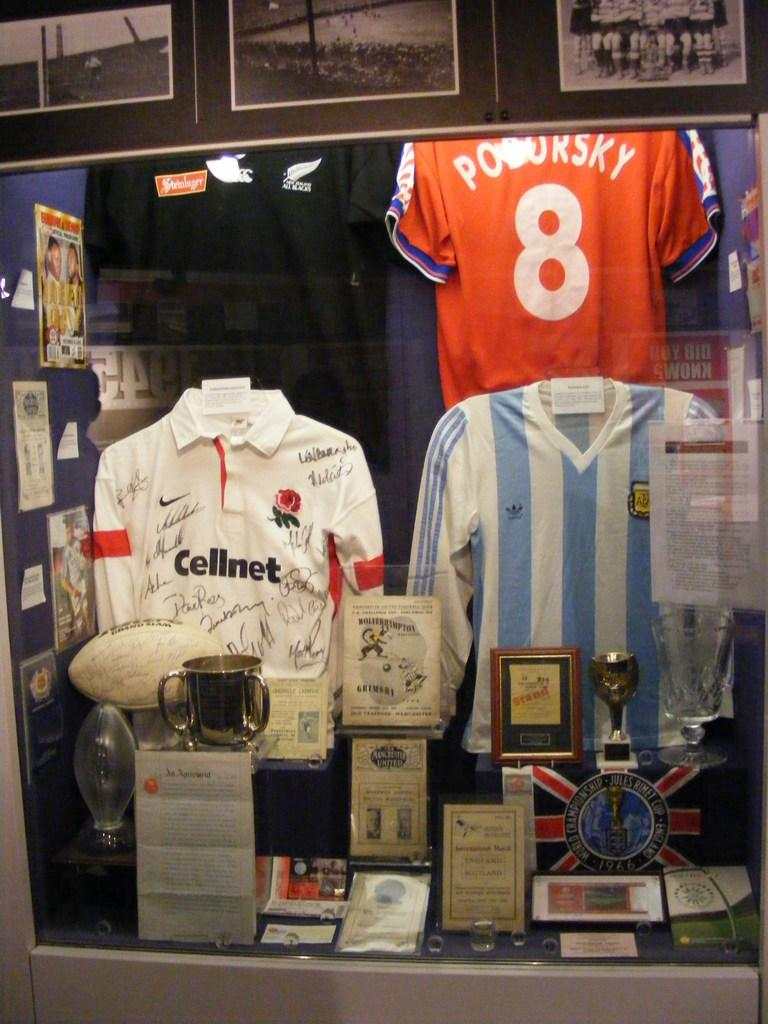Provide a one-sentence caption for the provided image. Three soccer's jerseys and the orange one have the number 8 on the back. 